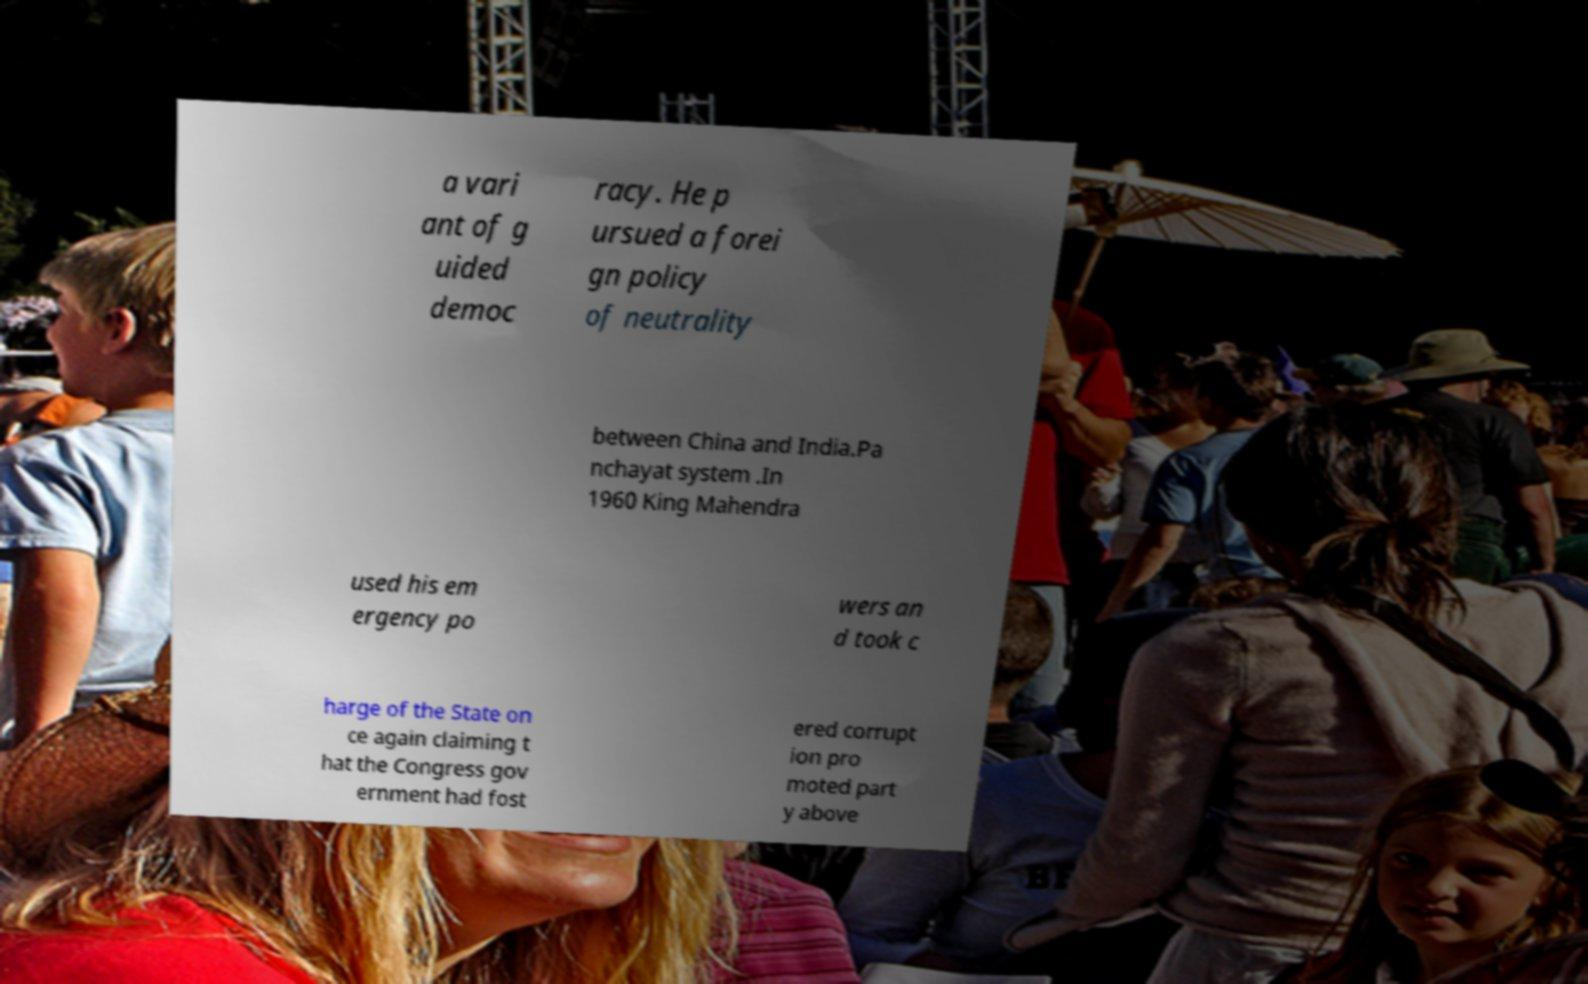Could you extract and type out the text from this image? a vari ant of g uided democ racy. He p ursued a forei gn policy of neutrality between China and India.Pa nchayat system .In 1960 King Mahendra used his em ergency po wers an d took c harge of the State on ce again claiming t hat the Congress gov ernment had fost ered corrupt ion pro moted part y above 